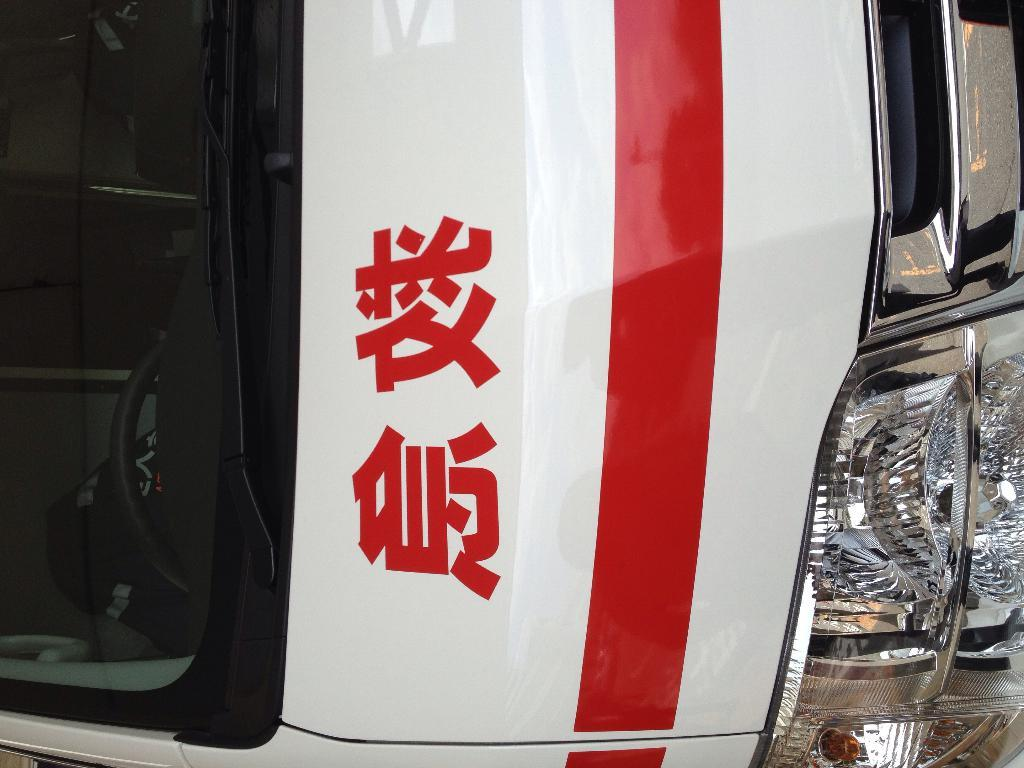What type of vehicle is shown in the image? The image shows the front view of a bus. Can you describe any specific features of the bus? Unfortunately, the provided facts do not mention any specific features of the bus. What might be the purpose of this bus? The purpose of the bus cannot be determined from the image alone. What type of boat is visible in the image? There is no boat present in the image; it shows the front view of a bus. How many coils can be seen wrapped around the shoe in the image? There is no shoe present in the image, and therefore no coils can be seen wrapped around it. 